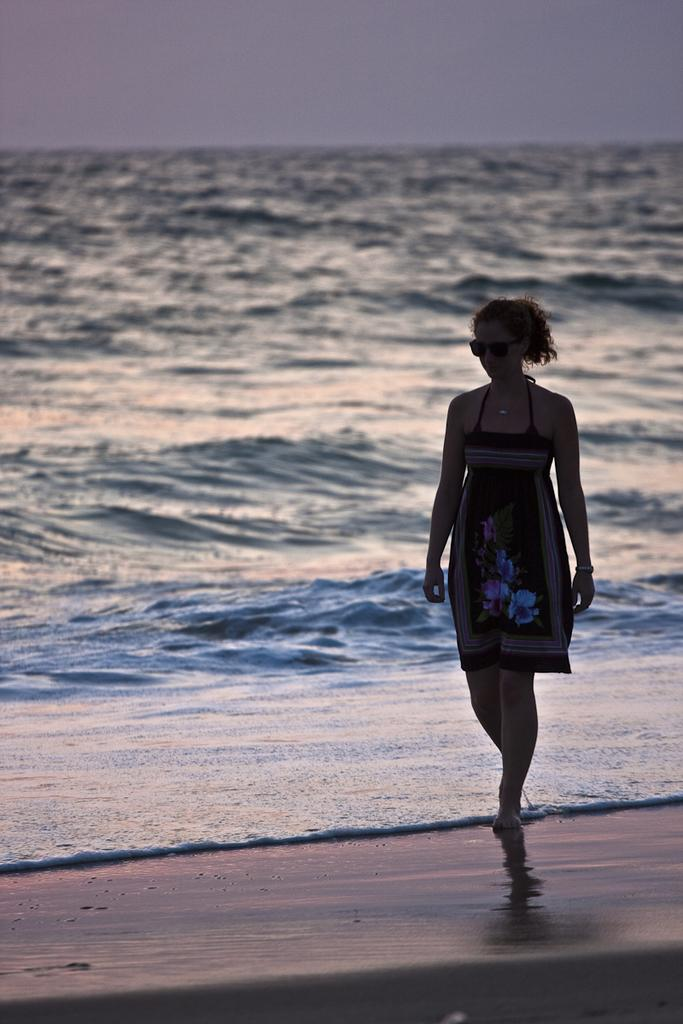Who is present in the image? There is a lady in the image. What is the lady doing in the image? The lady is walking on the sea shore. What can be seen in the background of the image? There is a sea visible in the background of the image. What type of jam is the lady spreading on the cheese in the image? There is no jam or cheese present in the image; the lady is walking on the sea shore with a sea visible in the background. 